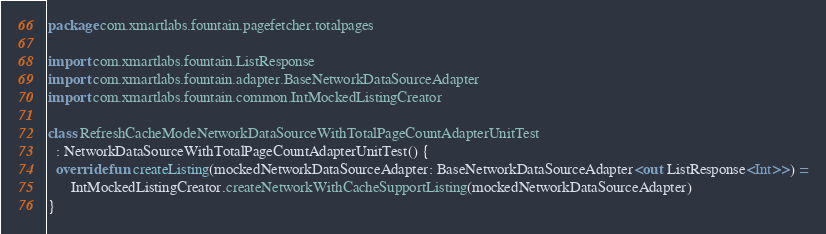Convert code to text. <code><loc_0><loc_0><loc_500><loc_500><_Kotlin_>package com.xmartlabs.fountain.pagefetcher.totalpages

import com.xmartlabs.fountain.ListResponse
import com.xmartlabs.fountain.adapter.BaseNetworkDataSourceAdapter
import com.xmartlabs.fountain.common.IntMockedListingCreator

class RefreshCacheModeNetworkDataSourceWithTotalPageCountAdapterUnitTest
  : NetworkDataSourceWithTotalPageCountAdapterUnitTest() {
  override fun createListing(mockedNetworkDataSourceAdapter: BaseNetworkDataSourceAdapter<out ListResponse<Int>>) =
      IntMockedListingCreator.createNetworkWithCacheSupportListing(mockedNetworkDataSourceAdapter)
}
</code> 